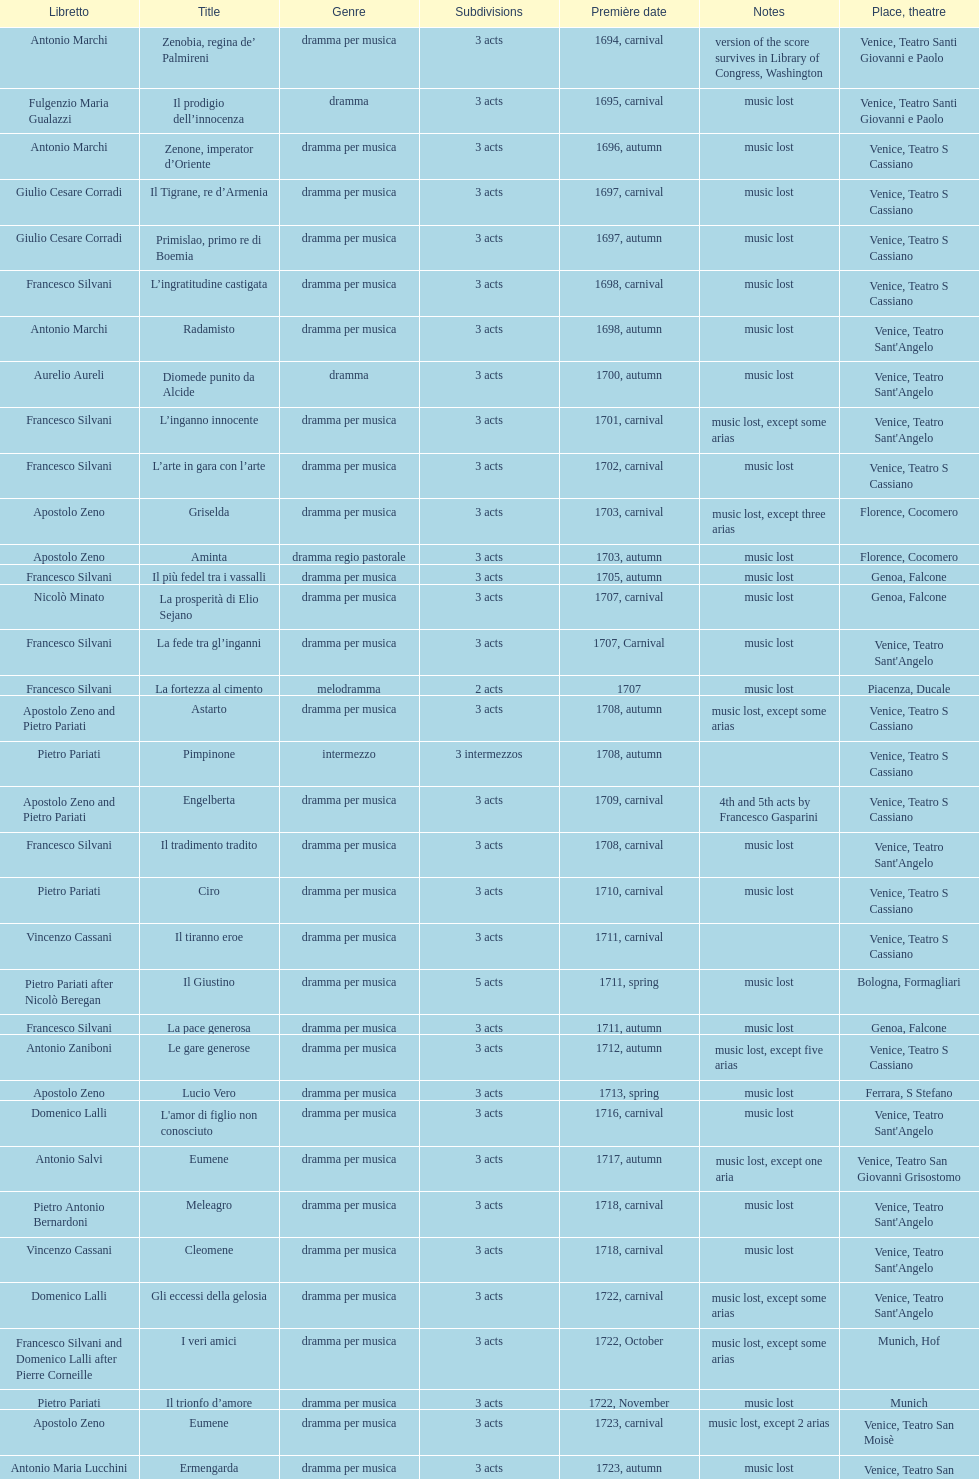Which was released earlier, artamene or merope? Merope. Could you help me parse every detail presented in this table? {'header': ['Libretto', 'Title', 'Genre', 'Sub\xaddivisions', 'Première date', 'Notes', 'Place, theatre'], 'rows': [['Antonio Marchi', 'Zenobia, regina de’ Palmireni', 'dramma per musica', '3 acts', '1694, carnival', 'version of the score survives in Library of Congress, Washington', 'Venice, Teatro Santi Giovanni e Paolo'], ['Fulgenzio Maria Gualazzi', 'Il prodigio dell’innocenza', 'dramma', '3 acts', '1695, carnival', 'music lost', 'Venice, Teatro Santi Giovanni e Paolo'], ['Antonio Marchi', 'Zenone, imperator d’Oriente', 'dramma per musica', '3 acts', '1696, autumn', 'music lost', 'Venice, Teatro S Cassiano'], ['Giulio Cesare Corradi', 'Il Tigrane, re d’Armenia', 'dramma per musica', '3 acts', '1697, carnival', 'music lost', 'Venice, Teatro S Cassiano'], ['Giulio Cesare Corradi', 'Primislao, primo re di Boemia', 'dramma per musica', '3 acts', '1697, autumn', 'music lost', 'Venice, Teatro S Cassiano'], ['Francesco Silvani', 'L’ingratitudine castigata', 'dramma per musica', '3 acts', '1698, carnival', 'music lost', 'Venice, Teatro S Cassiano'], ['Antonio Marchi', 'Radamisto', 'dramma per musica', '3 acts', '1698, autumn', 'music lost', "Venice, Teatro Sant'Angelo"], ['Aurelio Aureli', 'Diomede punito da Alcide', 'dramma', '3 acts', '1700, autumn', 'music lost', "Venice, Teatro Sant'Angelo"], ['Francesco Silvani', 'L’inganno innocente', 'dramma per musica', '3 acts', '1701, carnival', 'music lost, except some arias', "Venice, Teatro Sant'Angelo"], ['Francesco Silvani', 'L’arte in gara con l’arte', 'dramma per musica', '3 acts', '1702, carnival', 'music lost', 'Venice, Teatro S Cassiano'], ['Apostolo Zeno', 'Griselda', 'dramma per musica', '3 acts', '1703, carnival', 'music lost, except three arias', 'Florence, Cocomero'], ['Apostolo Zeno', 'Aminta', 'dramma regio pastorale', '3 acts', '1703, autumn', 'music lost', 'Florence, Cocomero'], ['Francesco Silvani', 'Il più fedel tra i vassalli', 'dramma per musica', '3 acts', '1705, autumn', 'music lost', 'Genoa, Falcone'], ['Nicolò Minato', 'La prosperità di Elio Sejano', 'dramma per musica', '3 acts', '1707, carnival', 'music lost', 'Genoa, Falcone'], ['Francesco Silvani', 'La fede tra gl’inganni', 'dramma per musica', '3 acts', '1707, Carnival', 'music lost', "Venice, Teatro Sant'Angelo"], ['Francesco Silvani', 'La fortezza al cimento', 'melodramma', '2 acts', '1707', 'music lost', 'Piacenza, Ducale'], ['Apostolo Zeno and Pietro Pariati', 'Astarto', 'dramma per musica', '3 acts', '1708, autumn', 'music lost, except some arias', 'Venice, Teatro S Cassiano'], ['Pietro Pariati', 'Pimpinone', 'intermezzo', '3 intermezzos', '1708, autumn', '', 'Venice, Teatro S Cassiano'], ['Apostolo Zeno and Pietro Pariati', 'Engelberta', 'dramma per musica', '3 acts', '1709, carnival', '4th and 5th acts by Francesco Gasparini', 'Venice, Teatro S Cassiano'], ['Francesco Silvani', 'Il tradimento tradito', 'dramma per musica', '3 acts', '1708, carnival', 'music lost', "Venice, Teatro Sant'Angelo"], ['Pietro Pariati', 'Ciro', 'dramma per musica', '3 acts', '1710, carnival', 'music lost', 'Venice, Teatro S Cassiano'], ['Vincenzo Cassani', 'Il tiranno eroe', 'dramma per musica', '3 acts', '1711, carnival', '', 'Venice, Teatro S Cassiano'], ['Pietro Pariati after Nicolò Beregan', 'Il Giustino', 'dramma per musica', '5 acts', '1711, spring', 'music lost', 'Bologna, Formagliari'], ['Francesco Silvani', 'La pace generosa', 'dramma per musica', '3 acts', '1711, autumn', 'music lost', 'Genoa, Falcone'], ['Antonio Zaniboni', 'Le gare generose', 'dramma per musica', '3 acts', '1712, autumn', 'music lost, except five arias', 'Venice, Teatro S Cassiano'], ['Apostolo Zeno', 'Lucio Vero', 'dramma per musica', '3 acts', '1713, spring', 'music lost', 'Ferrara, S Stefano'], ['Domenico Lalli', "L'amor di figlio non conosciuto", 'dramma per musica', '3 acts', '1716, carnival', 'music lost', "Venice, Teatro Sant'Angelo"], ['Antonio Salvi', 'Eumene', 'dramma per musica', '3 acts', '1717, autumn', 'music lost, except one aria', 'Venice, Teatro San Giovanni Grisostomo'], ['Pietro Antonio Bernardoni', 'Meleagro', 'dramma per musica', '3 acts', '1718, carnival', 'music lost', "Venice, Teatro Sant'Angelo"], ['Vincenzo Cassani', 'Cleomene', 'dramma per musica', '3 acts', '1718, carnival', 'music lost', "Venice, Teatro Sant'Angelo"], ['Domenico Lalli', 'Gli eccessi della gelosia', 'dramma per musica', '3 acts', '1722, carnival', 'music lost, except some arias', "Venice, Teatro Sant'Angelo"], ['Francesco Silvani and Domenico Lalli after Pierre Corneille', 'I veri amici', 'dramma per musica', '3 acts', '1722, October', 'music lost, except some arias', 'Munich, Hof'], ['Pietro Pariati', 'Il trionfo d’amore', 'dramma per musica', '3 acts', '1722, November', 'music lost', 'Munich'], ['Apostolo Zeno', 'Eumene', 'dramma per musica', '3 acts', '1723, carnival', 'music lost, except 2 arias', 'Venice, Teatro San Moisè'], ['Antonio Maria Lucchini', 'Ermengarda', 'dramma per musica', '3 acts', '1723, autumn', 'music lost', 'Venice, Teatro San Moisè'], ['Giovanni Piazzon', 'Antigono, tutore di Filippo, re di Macedonia', 'tragedia', '5 acts', '1724, carnival', '5th act by Giovanni Porta, music lost', 'Venice, Teatro San Moisè'], ['Apostolo Zeno', 'Scipione nelle Spagne', 'dramma per musica', '3 acts', '1724, Ascension', 'music lost', 'Venice, Teatro San Samuele'], ['Angelo Schietti', 'Laodice', 'dramma per musica', '3 acts', '1724, autumn', 'music lost, except 2 arias', 'Venice, Teatro San Moisè'], ['Metastasio', 'Didone abbandonata', 'tragedia', '3 acts', '1725, carnival', 'music lost', 'Venice, Teatro S Cassiano'], ['Metastasio', "L'impresario delle Isole Canarie", 'intermezzo', '2 acts', '1725, carnival', 'music lost', 'Venice, Teatro S Cassiano'], ['Antonio Marchi', 'Alcina delusa da Ruggero', 'dramma per musica', '3 acts', '1725, autumn', 'music lost', 'Venice, Teatro S Cassiano'], ['Apostolo Zeno', 'I rivali generosi', 'dramma per musica', '3 acts', '1725', '', 'Brescia, Nuovo'], ['Apostolo Zeno and Pietro Pariati', 'La Statira', 'dramma per musica', '3 acts', '1726, Carnival', '', 'Rome, Teatro Capranica'], ['', 'Malsazio e Fiammetta', 'intermezzo', '', '1726, Carnival', '', 'Rome, Teatro Capranica'], ['Girolamo Colatelli after Torquato Tasso', 'Il trionfo di Armida', 'dramma per musica', '3 acts', '1726, autumn', 'music lost', 'Venice, Teatro San Moisè'], ['Vincenzo Cassani', 'L’incostanza schernita', 'dramma comico-pastorale', '3 acts', '1727, Ascension', 'music lost, except some arias', 'Venice, Teatro San Samuele'], ['Aurelio Aureli', 'Le due rivali in amore', 'dramma per musica', '3 acts', '1728, autumn', 'music lost', 'Venice, Teatro San Moisè'], ['Salvi', 'Il Satrapone', 'intermezzo', '', '1729', '', 'Parma, Omodeo'], ['F Passerini', 'Li stratagemmi amorosi', 'dramma per musica', '3 acts', '1730, carnival', 'music lost', 'Venice, Teatro San Moisè'], ['Luisa Bergalli', 'Elenia', 'dramma per musica', '3 acts', '1730, carnival', 'music lost', "Venice, Teatro Sant'Angelo"], ['Apostolo Zeno', 'Merope', 'dramma', '3 acts', '1731, autumn', 'mostly by Albinoni, music lost', 'Prague, Sporck Theater'], ['Angelo Schietti', 'Il più infedel tra gli amanti', 'dramma per musica', '3 acts', '1731, autumn', 'music lost', 'Treviso, Dolphin'], ['Bartolomeo Vitturi', 'Ardelinda', 'dramma', '3 acts', '1732, autumn', 'music lost, except five arias', "Venice, Teatro Sant'Angelo"], ['Bartolomeo Vitturi', 'Candalide', 'dramma per musica', '3 acts', '1734, carnival', 'music lost', "Venice, Teatro Sant'Angelo"], ['Bartolomeo Vitturi', 'Artamene', 'dramma per musica', '3 acts', '1741, carnival', 'music lost', "Venice, Teatro Sant'Angelo"]]} 